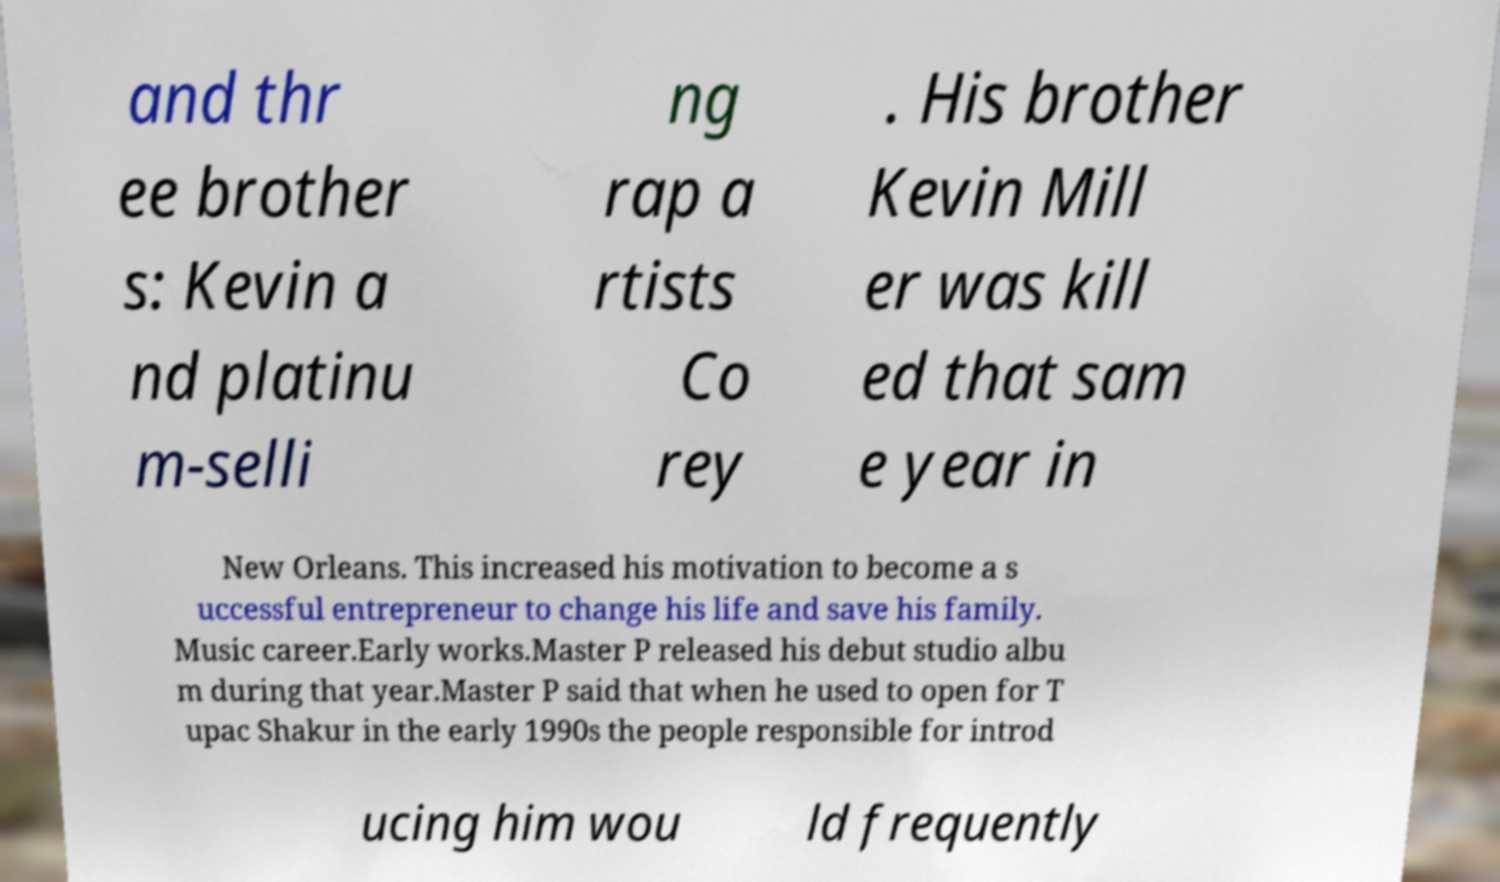Could you assist in decoding the text presented in this image and type it out clearly? and thr ee brother s: Kevin a nd platinu m-selli ng rap a rtists Co rey . His brother Kevin Mill er was kill ed that sam e year in New Orleans. This increased his motivation to become a s uccessful entrepreneur to change his life and save his family. Music career.Early works.Master P released his debut studio albu m during that year.Master P said that when he used to open for T upac Shakur in the early 1990s the people responsible for introd ucing him wou ld frequently 